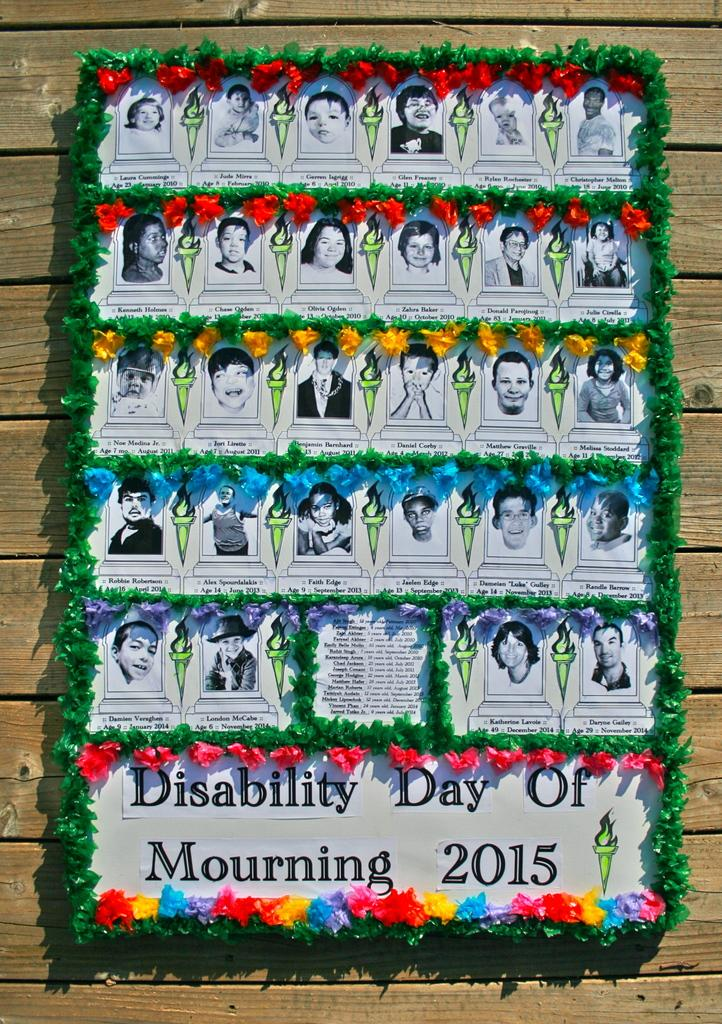What is present on the wall in the image? There is a poster in the image. What can be seen on the poster? The poster has images on it. How is the poster visually appealing? The poster is decorated. What type of wall can be seen in the background of the image? There is a wooden wall in the background of the image. Are there any deer or sheep visible in the image? No, there are no deer or sheep present in the image. 